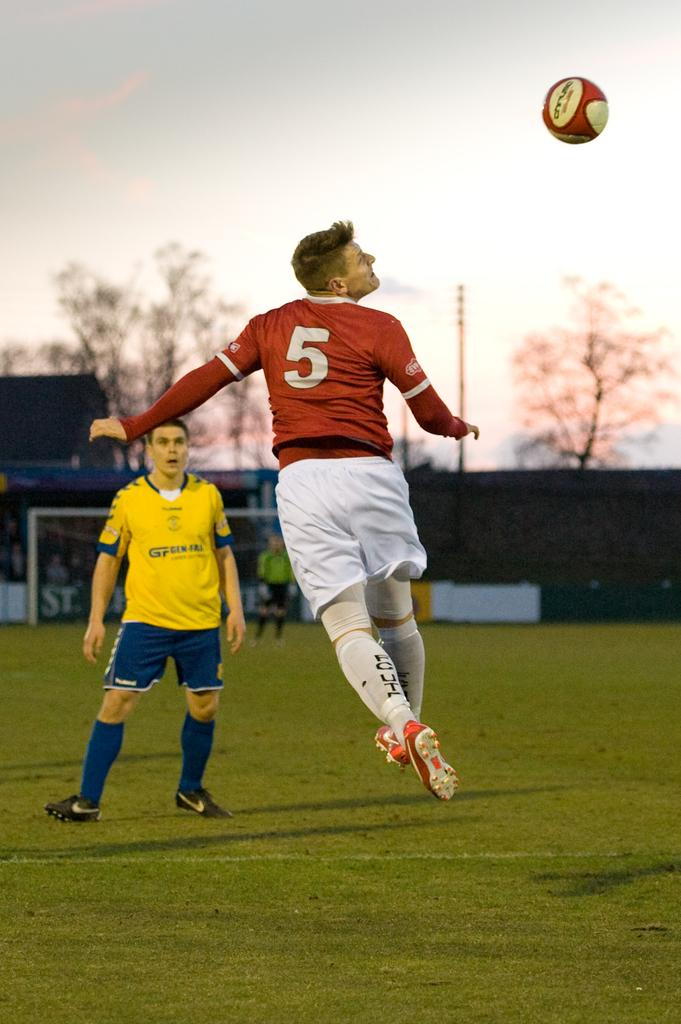<image>
Provide a brief description of the given image. A soccer player jumping into the air while wearing a red jersey with the number 5 on it. 